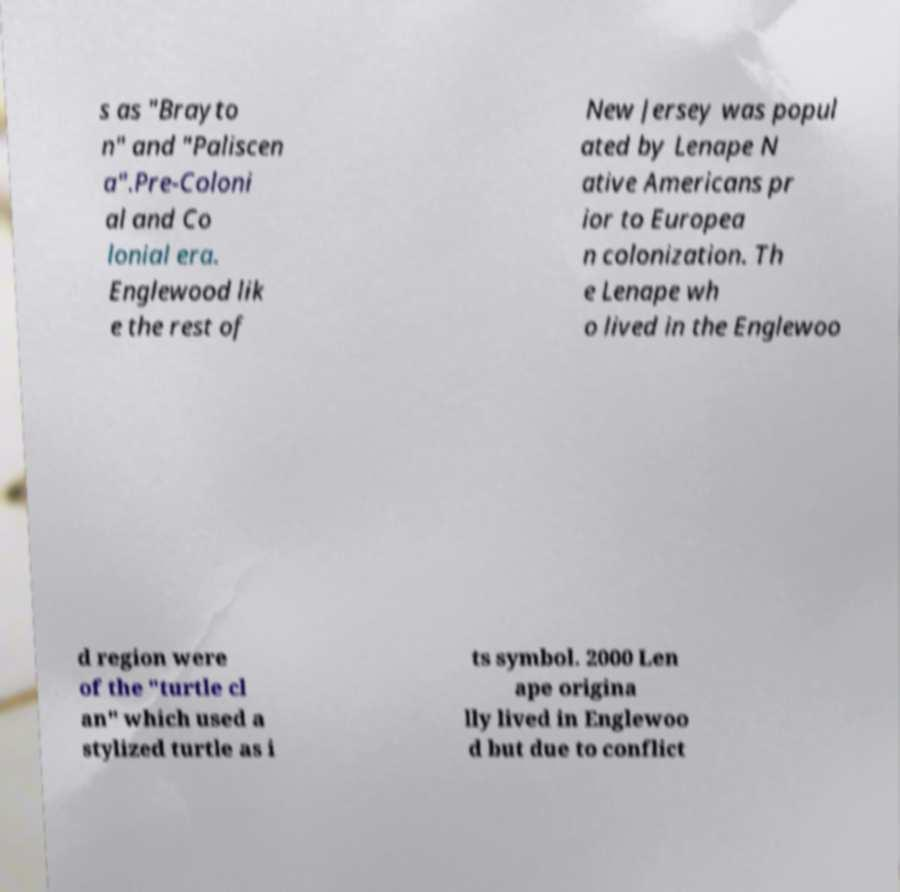Please read and relay the text visible in this image. What does it say? s as "Brayto n" and "Paliscen a".Pre-Coloni al and Co lonial era. Englewood lik e the rest of New Jersey was popul ated by Lenape N ative Americans pr ior to Europea n colonization. Th e Lenape wh o lived in the Englewoo d region were of the "turtle cl an" which used a stylized turtle as i ts symbol. 2000 Len ape origina lly lived in Englewoo d but due to conflict 